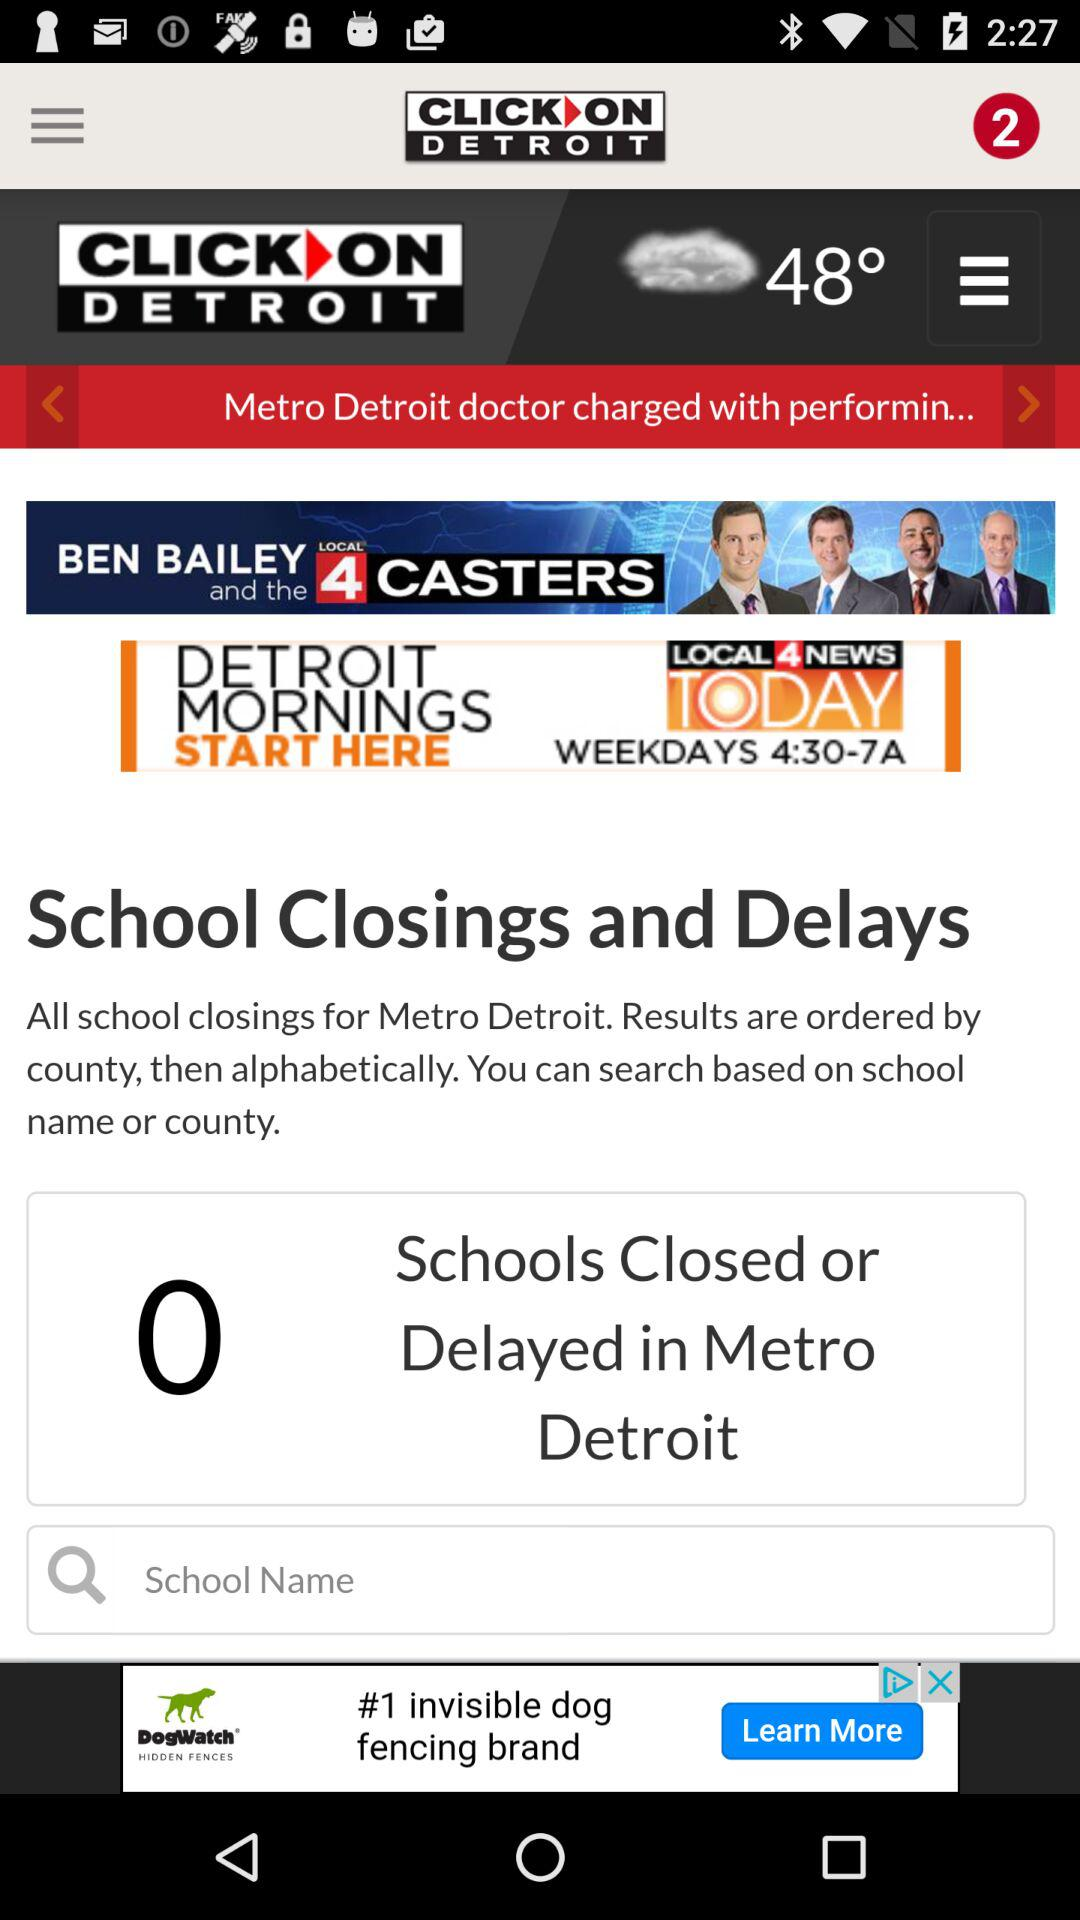What's the number of schools closed or delayed in Metro Detroit? The number of schools is zero. 